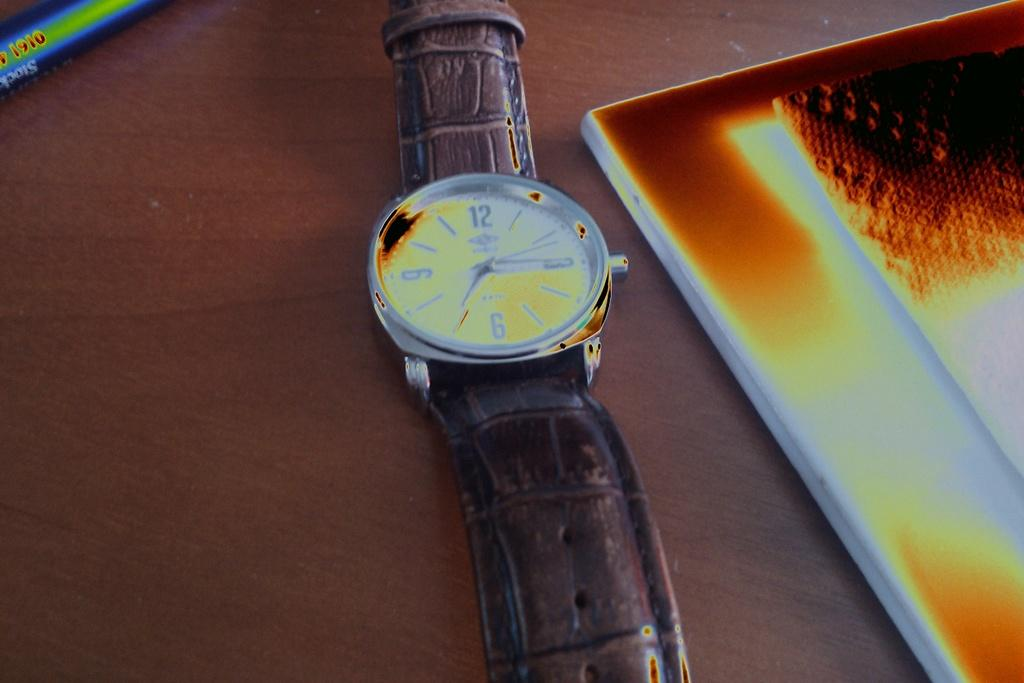Provide a one-sentence caption for the provided image. A wrist watch showing the time a quarter past seven lays on a table. 